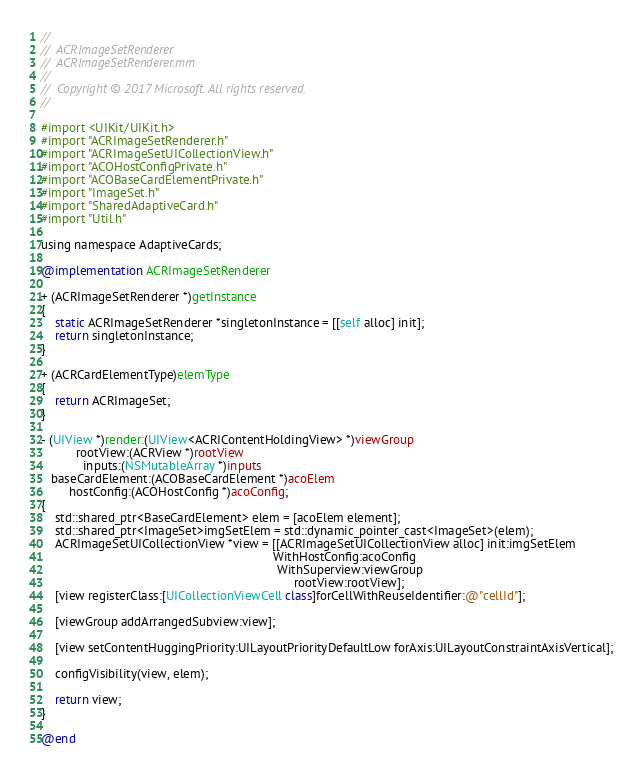Convert code to text. <code><loc_0><loc_0><loc_500><loc_500><_ObjectiveC_>//
//  ACRImageSetRenderer
//  ACRImageSetRenderer.mm
//
//  Copyright © 2017 Microsoft. All rights reserved.
//

#import <UIKit/UIKit.h>
#import "ACRImageSetRenderer.h"
#import "ACRImageSetUICollectionView.h"
#import "ACOHostConfigPrivate.h"
#import "ACOBaseCardElementPrivate.h"
#import "ImageSet.h"
#import "SharedAdaptiveCard.h"
#import "Util.h"

using namespace AdaptiveCards;

@implementation ACRImageSetRenderer

+ (ACRImageSetRenderer *)getInstance
{
    static ACRImageSetRenderer *singletonInstance = [[self alloc] init];
    return singletonInstance;
}

+ (ACRCardElementType)elemType
{
    return ACRImageSet;
}

- (UIView *)render:(UIView<ACRIContentHoldingView> *)viewGroup
          rootView:(ACRView *)rootView
            inputs:(NSMutableArray *)inputs
   baseCardElement:(ACOBaseCardElement *)acoElem
        hostConfig:(ACOHostConfig *)acoConfig;
{
    std::shared_ptr<BaseCardElement> elem = [acoElem element];
    std::shared_ptr<ImageSet>imgSetElem = std::dynamic_pointer_cast<ImageSet>(elem);
    ACRImageSetUICollectionView *view = [[ACRImageSetUICollectionView alloc] init:imgSetElem
                                                                   WithHostConfig:acoConfig
                                                                    WithSuperview:viewGroup
                                                                         rootView:rootView];
    [view registerClass:[UICollectionViewCell class]forCellWithReuseIdentifier:@"cellId"];

    [viewGroup addArrangedSubview:view];

    [view setContentHuggingPriority:UILayoutPriorityDefaultLow forAxis:UILayoutConstraintAxisVertical];

    configVisibility(view, elem);

    return view;
}

@end
</code> 